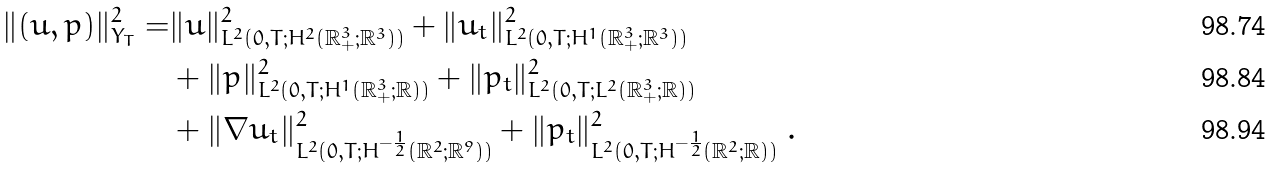<formula> <loc_0><loc_0><loc_500><loc_500>\| ( u , p ) \| ^ { 2 } _ { Y _ { T } } = & \| u \| ^ { 2 } _ { L ^ { 2 } ( 0 , T ; H ^ { 2 } ( { \mathbb { R } } ^ { 3 } _ { + } ; { \mathbb { R } } ^ { 3 } ) ) } + \| u _ { t } \| ^ { 2 } _ { L ^ { 2 } ( 0 , T ; H ^ { 1 } ( { \mathbb { R } } ^ { 3 } _ { + } ; { \mathbb { R } } ^ { 3 } ) ) } \\ & + \| p \| ^ { 2 } _ { L ^ { 2 } ( 0 , T ; H ^ { 1 } ( { \mathbb { R } } ^ { 3 } _ { + } ; { \mathbb { R } } ) ) } + \| p _ { t } \| ^ { 2 } _ { L ^ { 2 } ( 0 , T ; L ^ { 2 } ( { \mathbb { R } } ^ { 3 } _ { + } ; { \mathbb { R } } ) ) } \\ & + \| \nabla u _ { t } \| ^ { 2 } _ { L ^ { 2 } ( 0 , T ; H ^ { - \frac { 1 } { 2 } } ( { \mathbb { R } } ^ { 2 } ; { \mathbb { R } } ^ { 9 } ) ) } + \| p _ { t } \| ^ { 2 } _ { L ^ { 2 } ( 0 , T ; H ^ { - \frac { 1 } { 2 } } ( { \mathbb { R } } ^ { 2 } ; { \mathbb { R } } ) ) } \ .</formula> 